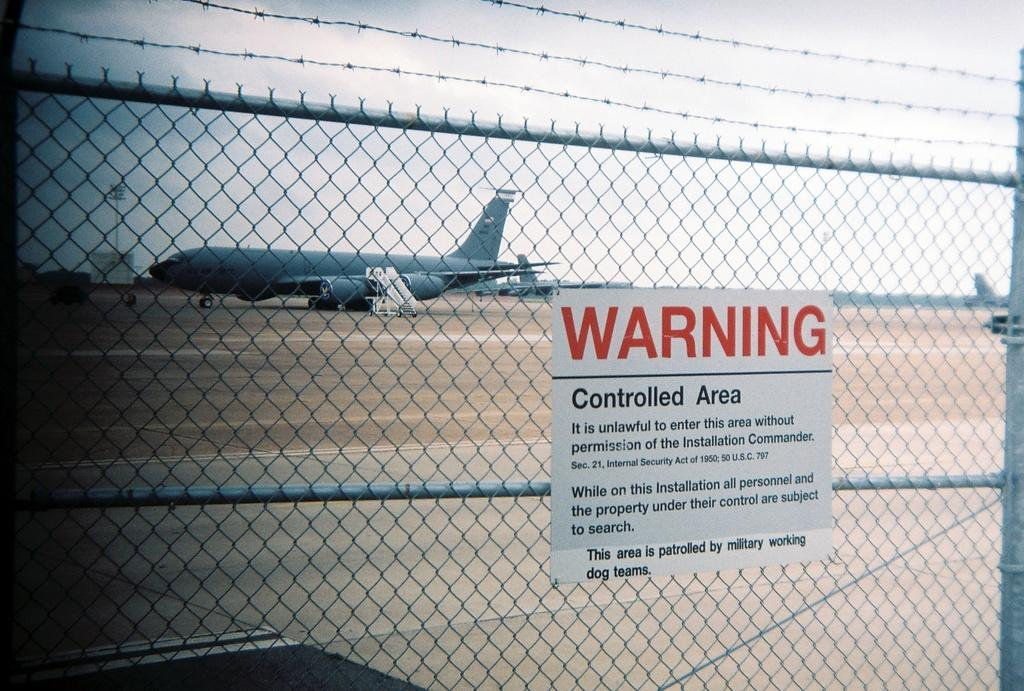Provide a one-sentence caption for the provided image. Fence that have a warning controlled area sign on it. 